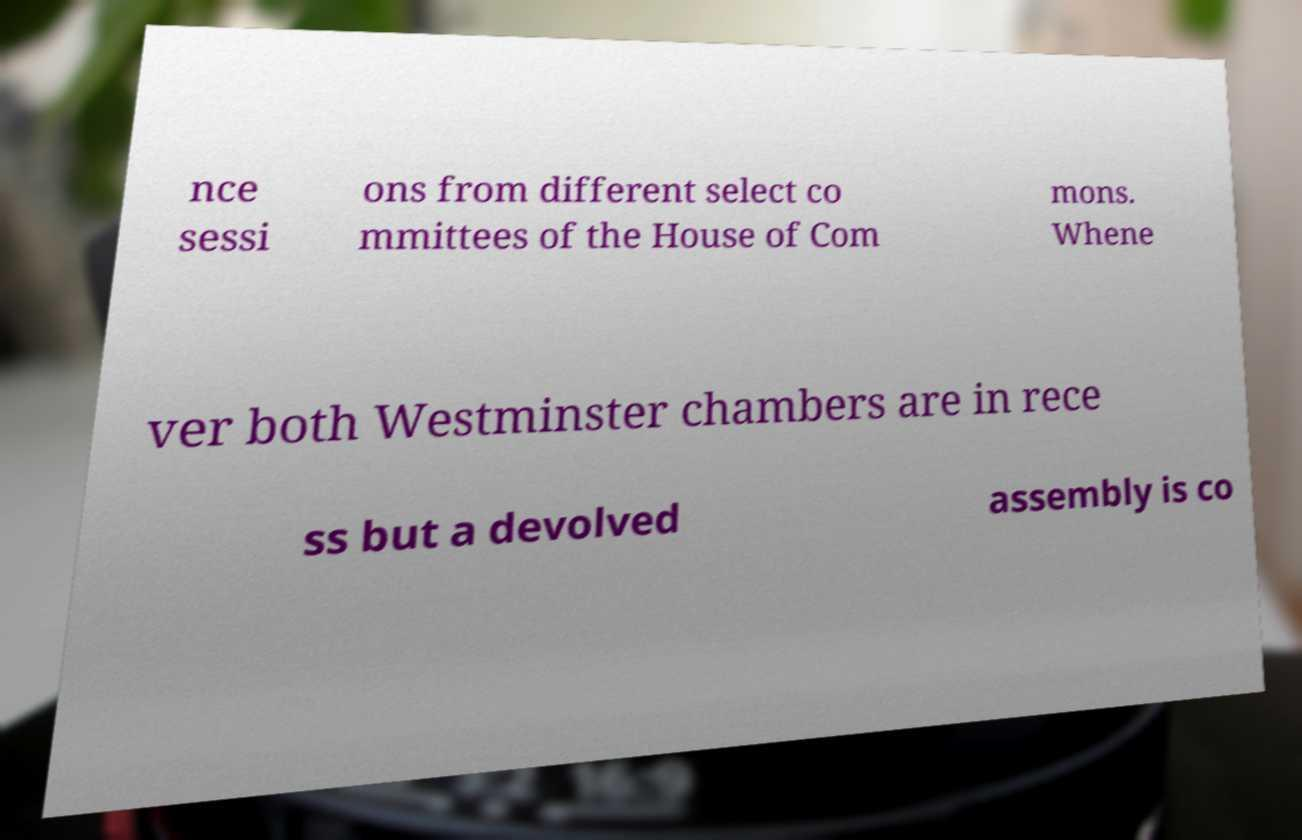Please identify and transcribe the text found in this image. nce sessi ons from different select co mmittees of the House of Com mons. Whene ver both Westminster chambers are in rece ss but a devolved assembly is co 